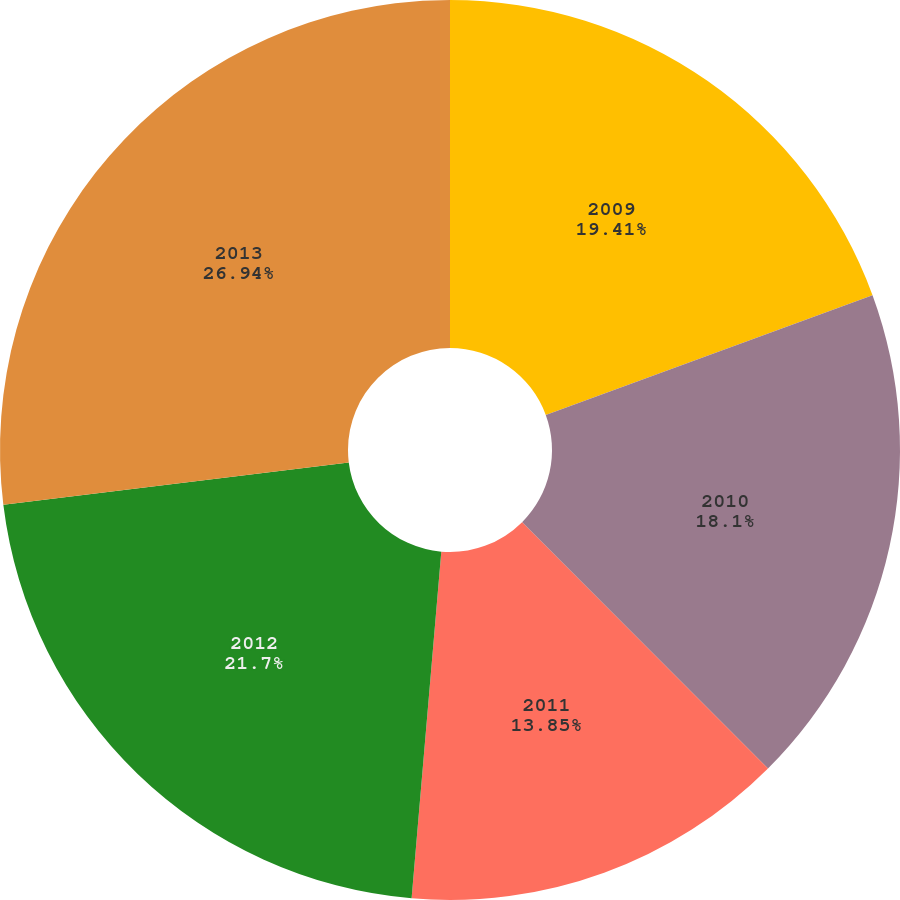<chart> <loc_0><loc_0><loc_500><loc_500><pie_chart><fcel>2009<fcel>2010<fcel>2011<fcel>2012<fcel>2013<nl><fcel>19.41%<fcel>18.1%<fcel>13.85%<fcel>21.7%<fcel>26.94%<nl></chart> 